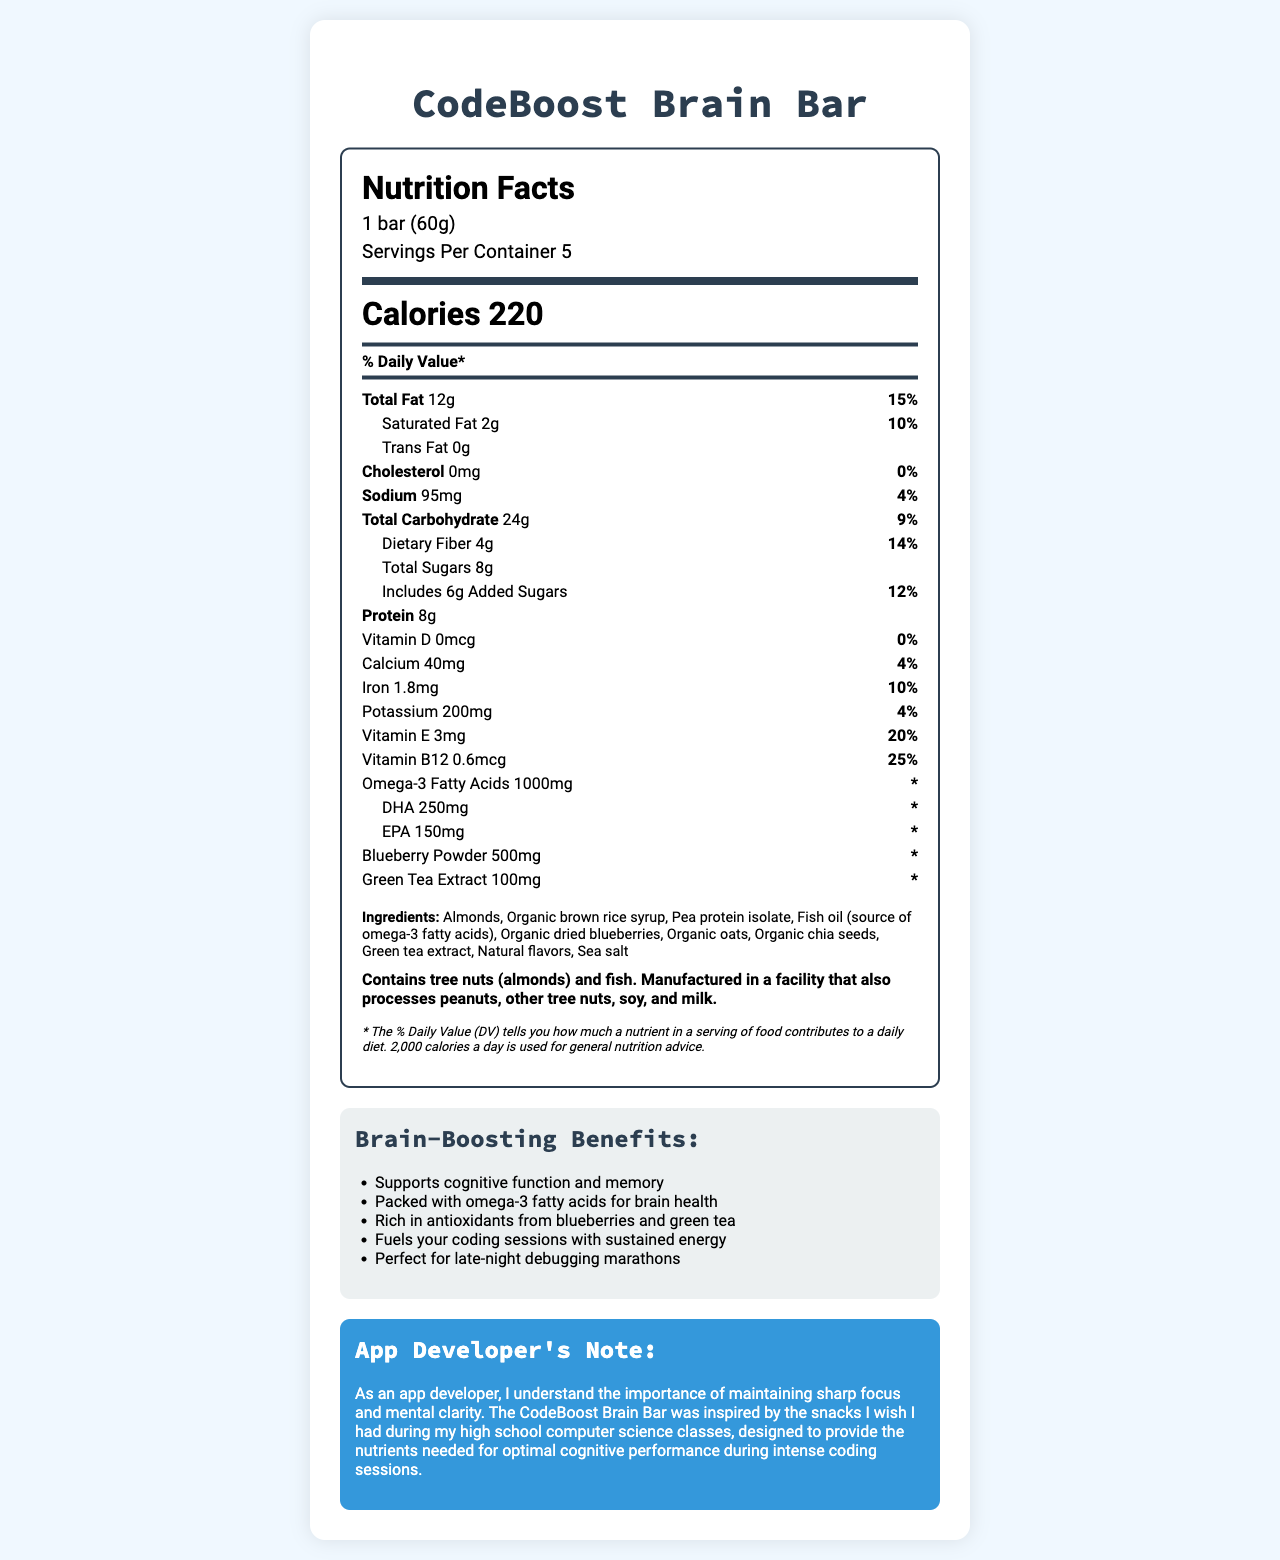what is the serving size of the CodeBoost Brain Bar? The serving size is explicitly stated in the document as "1 bar (60g)".
Answer: 1 bar (60g) how many calories are in one serving? According to the document, each serving contains 220 calories.
Answer: 220 how many grams of total fat are in one bar? The total fat content per serving is listed as 12g.
Answer: 12g how many servings are there per container? The document specifies "Servings Per Container 5".
Answer: 5 does the CodeBoost Brain Bar contain any trans fat? The document lists Trans Fat as "0g", indicating no trans fat is present.
Answer: No which ingredient provides omega-3 fatty acids? Among the ingredients listed, fish oil is identified as the source of omega-3 fatty acids.
Answer: Fish oil how much dietary fiber does one bar contain? The dietary fiber content per serving is stated to be 4g.
Answer: 4g what are the two main antioxidants present in the CodeBoost Brain Bar? The document lists blueberry powder and green tea extract as ingredients, which are known antioxidants.
Answer: Blueberry powder and green tea extract how much cholesterol is in one serving of the bar? The bar contains 0mg of cholesterol as per the document.
Answer: 0mg how many grams of protein does each bar provide? Each serving contains 8g of protein.
Answer: 8g which of the following nutrients does the bar provide the highest % Daily Value? A. Calcium B. Iron C. Vitamin E D. Vitamin B12 The % Daily Value for Vitamin B12 is 25%, which is the highest among the options listed.
Answer: D. Vitamin B12 which type of nuts is included in the ingredients? A. Almonds B. Peanuts C. Walnuts D. Cashews The document lists almonds as one of the ingredients.
Answer: A. Almonds is the CodeBoost Brain Bar suitable for someone with a peanut allergy? The allergen information states the bar is manufactured in a facility that also processes peanuts.
Answer: No what is the % daily value of saturated fat per serving? The document lists the % daily value for saturated fat as 10%.
Answer: 10% does the CodeBoost Brain Bar contain added sugars? The bar includes 6g of added sugars as specified in the document.
Answer: Yes summarize the main idea of the document. The explanation covers key points about the product's nutritional facts, health benefits, and targeted audience as presented in the document.
Answer: The document provides detailed nutritional information for the CodeBoost Brain Bar, including its serving size, calories, fat content, and key ingredients. It highlights the bar’s benefits for cognitive function due to its omega-3 fatty acids and antioxidants. The bar is particularly suggested as an ideal snack for sustained energy during coding sessions, with an additional note from an app developer emphasizing its cognitive benefits. where does the product claim to be especially useful? The marketing claims state that the bar is perfect for late-night debugging marathons and fuels coding sessions with sustained energy.
Answer: Coding sessions what is the daily value percentage of iron in one serving? The document states the daily value percentage of iron as 10%.
Answer: 10% what allergens are present in the CodeBoost Brain Bar? The allergen information specifies the presence of tree nuts (almonds) and fish.
Answer: Tree nuts (almonds) and fish can you determine the source of the organic dried blueberries? The document mentions "organic dried blueberries" as an ingredient but does not provide information on their source.
Answer: Cannot be determined 